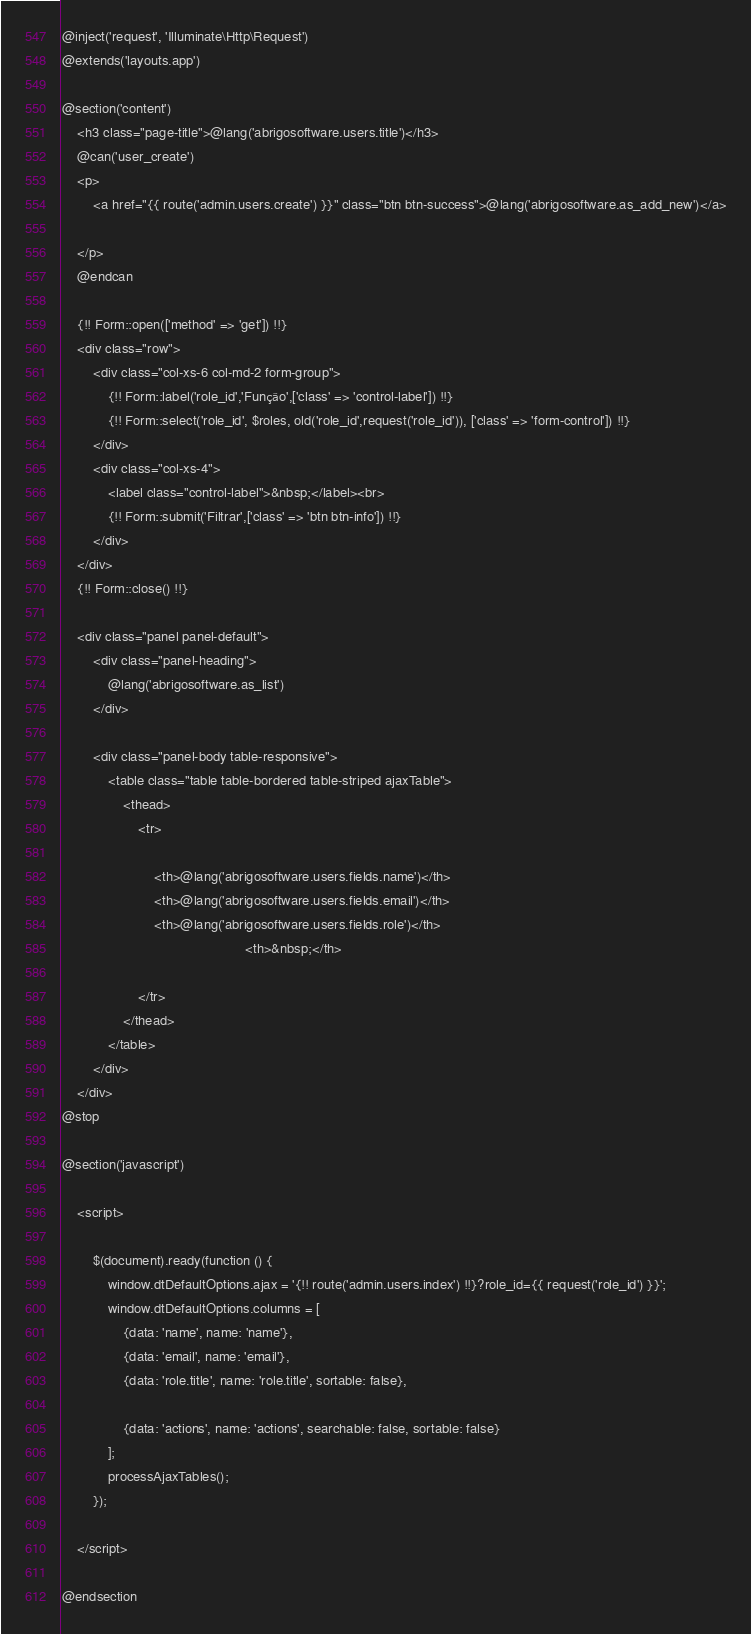Convert code to text. <code><loc_0><loc_0><loc_500><loc_500><_PHP_>@inject('request', 'Illuminate\Http\Request')
@extends('layouts.app')

@section('content')
    <h3 class="page-title">@lang('abrigosoftware.users.title')</h3>
    @can('user_create')
    <p>
        <a href="{{ route('admin.users.create') }}" class="btn btn-success">@lang('abrigosoftware.as_add_new')</a>
        
    </p>
    @endcan

    {!! Form::open(['method' => 'get']) !!}
    <div class="row">
        <div class="col-xs-6 col-md-2 form-group">
            {!! Form::label('role_id','Função',['class' => 'control-label']) !!}
            {!! Form::select('role_id', $roles, old('role_id',request('role_id')), ['class' => 'form-control']) !!}
        </div>
        <div class="col-xs-4">
            <label class="control-label">&nbsp;</label><br>
            {!! Form::submit('Filtrar',['class' => 'btn btn-info']) !!}
        </div>
    </div>
    {!! Form::close() !!}

    <div class="panel panel-default">
        <div class="panel-heading">
            @lang('abrigosoftware.as_list')
        </div>

        <div class="panel-body table-responsive">
            <table class="table table-bordered table-striped ajaxTable">
                <thead>
                    <tr>

                        <th>@lang('abrigosoftware.users.fields.name')</th>
                        <th>@lang('abrigosoftware.users.fields.email')</th>
                        <th>@lang('abrigosoftware.users.fields.role')</th>
                                                <th>&nbsp;</th>

                    </tr>
                </thead>
            </table>
        </div>
    </div>
@stop

@section('javascript') 

    <script>

        $(document).ready(function () {
            window.dtDefaultOptions.ajax = '{!! route('admin.users.index') !!}?role_id={{ request('role_id') }}';
            window.dtDefaultOptions.columns = [
                {data: 'name', name: 'name'},
                {data: 'email', name: 'email'},
                {data: 'role.title', name: 'role.title', sortable: false},
                
                {data: 'actions', name: 'actions', searchable: false, sortable: false}
            ];
            processAjaxTables();
        });

    </script>

@endsection</code> 